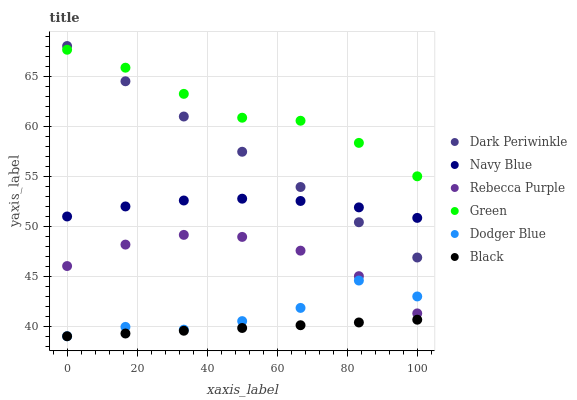Does Black have the minimum area under the curve?
Answer yes or no. Yes. Does Green have the maximum area under the curve?
Answer yes or no. Yes. Does Dodger Blue have the minimum area under the curve?
Answer yes or no. No. Does Dodger Blue have the maximum area under the curve?
Answer yes or no. No. Is Dark Periwinkle the smoothest?
Answer yes or no. Yes. Is Dodger Blue the roughest?
Answer yes or no. Yes. Is Black the smoothest?
Answer yes or no. No. Is Black the roughest?
Answer yes or no. No. Does Dodger Blue have the lowest value?
Answer yes or no. Yes. Does Rebecca Purple have the lowest value?
Answer yes or no. No. Does Dark Periwinkle have the highest value?
Answer yes or no. Yes. Does Dodger Blue have the highest value?
Answer yes or no. No. Is Rebecca Purple less than Dark Periwinkle?
Answer yes or no. Yes. Is Rebecca Purple greater than Black?
Answer yes or no. Yes. Does Green intersect Dark Periwinkle?
Answer yes or no. Yes. Is Green less than Dark Periwinkle?
Answer yes or no. No. Is Green greater than Dark Periwinkle?
Answer yes or no. No. Does Rebecca Purple intersect Dark Periwinkle?
Answer yes or no. No. 